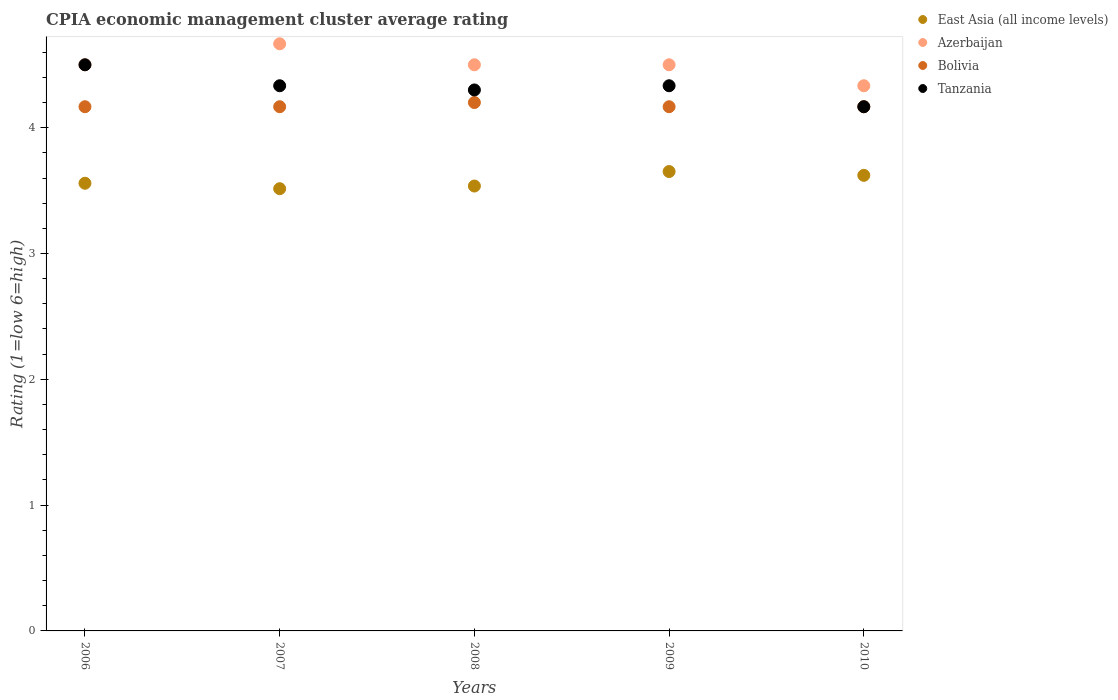How many different coloured dotlines are there?
Provide a succinct answer. 4. Is the number of dotlines equal to the number of legend labels?
Offer a terse response. Yes. What is the CPIA rating in Tanzania in 2009?
Your response must be concise. 4.33. Across all years, what is the maximum CPIA rating in Tanzania?
Offer a very short reply. 4.5. Across all years, what is the minimum CPIA rating in Azerbaijan?
Keep it short and to the point. 4.33. In which year was the CPIA rating in Bolivia maximum?
Ensure brevity in your answer.  2008. What is the total CPIA rating in Tanzania in the graph?
Your response must be concise. 21.63. What is the difference between the CPIA rating in East Asia (all income levels) in 2007 and that in 2010?
Offer a terse response. -0.11. What is the difference between the CPIA rating in Bolivia in 2006 and the CPIA rating in Azerbaijan in 2009?
Your answer should be compact. -0.33. What is the average CPIA rating in Bolivia per year?
Your response must be concise. 4.17. In the year 2008, what is the difference between the CPIA rating in East Asia (all income levels) and CPIA rating in Tanzania?
Your answer should be compact. -0.76. In how many years, is the CPIA rating in East Asia (all income levels) greater than 1?
Your answer should be compact. 5. What is the ratio of the CPIA rating in Bolivia in 2008 to that in 2010?
Give a very brief answer. 1.01. Is the CPIA rating in East Asia (all income levels) in 2007 less than that in 2008?
Your answer should be very brief. Yes. Is the difference between the CPIA rating in East Asia (all income levels) in 2008 and 2009 greater than the difference between the CPIA rating in Tanzania in 2008 and 2009?
Give a very brief answer. No. What is the difference between the highest and the second highest CPIA rating in East Asia (all income levels)?
Give a very brief answer. 0.03. What is the difference between the highest and the lowest CPIA rating in Tanzania?
Provide a succinct answer. 0.33. In how many years, is the CPIA rating in Tanzania greater than the average CPIA rating in Tanzania taken over all years?
Provide a succinct answer. 3. Is the sum of the CPIA rating in East Asia (all income levels) in 2009 and 2010 greater than the maximum CPIA rating in Azerbaijan across all years?
Give a very brief answer. Yes. Is it the case that in every year, the sum of the CPIA rating in Azerbaijan and CPIA rating in Tanzania  is greater than the sum of CPIA rating in East Asia (all income levels) and CPIA rating in Bolivia?
Make the answer very short. No. Does the CPIA rating in Bolivia monotonically increase over the years?
Provide a short and direct response. No. Is the CPIA rating in Azerbaijan strictly less than the CPIA rating in Tanzania over the years?
Provide a short and direct response. No. How many years are there in the graph?
Give a very brief answer. 5. Are the values on the major ticks of Y-axis written in scientific E-notation?
Ensure brevity in your answer.  No. Does the graph contain any zero values?
Ensure brevity in your answer.  No. Does the graph contain grids?
Offer a very short reply. No. What is the title of the graph?
Provide a succinct answer. CPIA economic management cluster average rating. What is the Rating (1=low 6=high) of East Asia (all income levels) in 2006?
Ensure brevity in your answer.  3.56. What is the Rating (1=low 6=high) of Azerbaijan in 2006?
Your answer should be very brief. 4.5. What is the Rating (1=low 6=high) in Bolivia in 2006?
Your answer should be compact. 4.17. What is the Rating (1=low 6=high) of East Asia (all income levels) in 2007?
Your answer should be compact. 3.52. What is the Rating (1=low 6=high) in Azerbaijan in 2007?
Make the answer very short. 4.67. What is the Rating (1=low 6=high) of Bolivia in 2007?
Offer a very short reply. 4.17. What is the Rating (1=low 6=high) in Tanzania in 2007?
Offer a very short reply. 4.33. What is the Rating (1=low 6=high) of East Asia (all income levels) in 2008?
Your response must be concise. 3.54. What is the Rating (1=low 6=high) of Bolivia in 2008?
Ensure brevity in your answer.  4.2. What is the Rating (1=low 6=high) of East Asia (all income levels) in 2009?
Offer a very short reply. 3.65. What is the Rating (1=low 6=high) in Azerbaijan in 2009?
Your answer should be compact. 4.5. What is the Rating (1=low 6=high) of Bolivia in 2009?
Your response must be concise. 4.17. What is the Rating (1=low 6=high) in Tanzania in 2009?
Make the answer very short. 4.33. What is the Rating (1=low 6=high) in East Asia (all income levels) in 2010?
Make the answer very short. 3.62. What is the Rating (1=low 6=high) of Azerbaijan in 2010?
Your answer should be compact. 4.33. What is the Rating (1=low 6=high) of Bolivia in 2010?
Keep it short and to the point. 4.17. What is the Rating (1=low 6=high) of Tanzania in 2010?
Your answer should be compact. 4.17. Across all years, what is the maximum Rating (1=low 6=high) in East Asia (all income levels)?
Your answer should be very brief. 3.65. Across all years, what is the maximum Rating (1=low 6=high) of Azerbaijan?
Offer a very short reply. 4.67. Across all years, what is the minimum Rating (1=low 6=high) in East Asia (all income levels)?
Offer a terse response. 3.52. Across all years, what is the minimum Rating (1=low 6=high) in Azerbaijan?
Provide a short and direct response. 4.33. Across all years, what is the minimum Rating (1=low 6=high) of Bolivia?
Offer a terse response. 4.17. Across all years, what is the minimum Rating (1=low 6=high) of Tanzania?
Your answer should be compact. 4.17. What is the total Rating (1=low 6=high) of East Asia (all income levels) in the graph?
Your answer should be compact. 17.88. What is the total Rating (1=low 6=high) in Bolivia in the graph?
Offer a very short reply. 20.87. What is the total Rating (1=low 6=high) in Tanzania in the graph?
Ensure brevity in your answer.  21.63. What is the difference between the Rating (1=low 6=high) of East Asia (all income levels) in 2006 and that in 2007?
Give a very brief answer. 0.04. What is the difference between the Rating (1=low 6=high) of Bolivia in 2006 and that in 2007?
Keep it short and to the point. 0. What is the difference between the Rating (1=low 6=high) in East Asia (all income levels) in 2006 and that in 2008?
Your answer should be compact. 0.02. What is the difference between the Rating (1=low 6=high) in Azerbaijan in 2006 and that in 2008?
Provide a short and direct response. 0. What is the difference between the Rating (1=low 6=high) in Bolivia in 2006 and that in 2008?
Your response must be concise. -0.03. What is the difference between the Rating (1=low 6=high) in Tanzania in 2006 and that in 2008?
Provide a succinct answer. 0.2. What is the difference between the Rating (1=low 6=high) in East Asia (all income levels) in 2006 and that in 2009?
Ensure brevity in your answer.  -0.09. What is the difference between the Rating (1=low 6=high) of Bolivia in 2006 and that in 2009?
Provide a succinct answer. 0. What is the difference between the Rating (1=low 6=high) in Tanzania in 2006 and that in 2009?
Give a very brief answer. 0.17. What is the difference between the Rating (1=low 6=high) of East Asia (all income levels) in 2006 and that in 2010?
Offer a very short reply. -0.06. What is the difference between the Rating (1=low 6=high) in Bolivia in 2006 and that in 2010?
Provide a short and direct response. 0. What is the difference between the Rating (1=low 6=high) of East Asia (all income levels) in 2007 and that in 2008?
Your response must be concise. -0.02. What is the difference between the Rating (1=low 6=high) in Azerbaijan in 2007 and that in 2008?
Offer a very short reply. 0.17. What is the difference between the Rating (1=low 6=high) of Bolivia in 2007 and that in 2008?
Offer a terse response. -0.03. What is the difference between the Rating (1=low 6=high) of East Asia (all income levels) in 2007 and that in 2009?
Make the answer very short. -0.14. What is the difference between the Rating (1=low 6=high) in Bolivia in 2007 and that in 2009?
Offer a very short reply. 0. What is the difference between the Rating (1=low 6=high) of East Asia (all income levels) in 2007 and that in 2010?
Ensure brevity in your answer.  -0.11. What is the difference between the Rating (1=low 6=high) of Azerbaijan in 2007 and that in 2010?
Give a very brief answer. 0.33. What is the difference between the Rating (1=low 6=high) in Bolivia in 2007 and that in 2010?
Provide a succinct answer. 0. What is the difference between the Rating (1=low 6=high) of East Asia (all income levels) in 2008 and that in 2009?
Offer a terse response. -0.12. What is the difference between the Rating (1=low 6=high) in Bolivia in 2008 and that in 2009?
Ensure brevity in your answer.  0.03. What is the difference between the Rating (1=low 6=high) of Tanzania in 2008 and that in 2009?
Your answer should be very brief. -0.03. What is the difference between the Rating (1=low 6=high) of East Asia (all income levels) in 2008 and that in 2010?
Your response must be concise. -0.08. What is the difference between the Rating (1=low 6=high) of Azerbaijan in 2008 and that in 2010?
Provide a short and direct response. 0.17. What is the difference between the Rating (1=low 6=high) in Bolivia in 2008 and that in 2010?
Make the answer very short. 0.03. What is the difference between the Rating (1=low 6=high) in Tanzania in 2008 and that in 2010?
Provide a succinct answer. 0.13. What is the difference between the Rating (1=low 6=high) in East Asia (all income levels) in 2009 and that in 2010?
Keep it short and to the point. 0.03. What is the difference between the Rating (1=low 6=high) of Bolivia in 2009 and that in 2010?
Offer a very short reply. 0. What is the difference between the Rating (1=low 6=high) in Tanzania in 2009 and that in 2010?
Keep it short and to the point. 0.17. What is the difference between the Rating (1=low 6=high) of East Asia (all income levels) in 2006 and the Rating (1=low 6=high) of Azerbaijan in 2007?
Your answer should be compact. -1.11. What is the difference between the Rating (1=low 6=high) of East Asia (all income levels) in 2006 and the Rating (1=low 6=high) of Bolivia in 2007?
Offer a terse response. -0.61. What is the difference between the Rating (1=low 6=high) of East Asia (all income levels) in 2006 and the Rating (1=low 6=high) of Tanzania in 2007?
Keep it short and to the point. -0.78. What is the difference between the Rating (1=low 6=high) in Azerbaijan in 2006 and the Rating (1=low 6=high) in Bolivia in 2007?
Keep it short and to the point. 0.33. What is the difference between the Rating (1=low 6=high) of Azerbaijan in 2006 and the Rating (1=low 6=high) of Tanzania in 2007?
Provide a short and direct response. 0.17. What is the difference between the Rating (1=low 6=high) in Bolivia in 2006 and the Rating (1=low 6=high) in Tanzania in 2007?
Your response must be concise. -0.17. What is the difference between the Rating (1=low 6=high) of East Asia (all income levels) in 2006 and the Rating (1=low 6=high) of Azerbaijan in 2008?
Offer a very short reply. -0.94. What is the difference between the Rating (1=low 6=high) in East Asia (all income levels) in 2006 and the Rating (1=low 6=high) in Bolivia in 2008?
Provide a short and direct response. -0.64. What is the difference between the Rating (1=low 6=high) of East Asia (all income levels) in 2006 and the Rating (1=low 6=high) of Tanzania in 2008?
Offer a terse response. -0.74. What is the difference between the Rating (1=low 6=high) in Azerbaijan in 2006 and the Rating (1=low 6=high) in Bolivia in 2008?
Provide a succinct answer. 0.3. What is the difference between the Rating (1=low 6=high) of Bolivia in 2006 and the Rating (1=low 6=high) of Tanzania in 2008?
Your answer should be very brief. -0.13. What is the difference between the Rating (1=low 6=high) in East Asia (all income levels) in 2006 and the Rating (1=low 6=high) in Azerbaijan in 2009?
Make the answer very short. -0.94. What is the difference between the Rating (1=low 6=high) in East Asia (all income levels) in 2006 and the Rating (1=low 6=high) in Bolivia in 2009?
Keep it short and to the point. -0.61. What is the difference between the Rating (1=low 6=high) of East Asia (all income levels) in 2006 and the Rating (1=low 6=high) of Tanzania in 2009?
Your answer should be very brief. -0.78. What is the difference between the Rating (1=low 6=high) in Azerbaijan in 2006 and the Rating (1=low 6=high) in Bolivia in 2009?
Give a very brief answer. 0.33. What is the difference between the Rating (1=low 6=high) of Bolivia in 2006 and the Rating (1=low 6=high) of Tanzania in 2009?
Offer a terse response. -0.17. What is the difference between the Rating (1=low 6=high) in East Asia (all income levels) in 2006 and the Rating (1=low 6=high) in Azerbaijan in 2010?
Your answer should be very brief. -0.78. What is the difference between the Rating (1=low 6=high) in East Asia (all income levels) in 2006 and the Rating (1=low 6=high) in Bolivia in 2010?
Offer a very short reply. -0.61. What is the difference between the Rating (1=low 6=high) in East Asia (all income levels) in 2006 and the Rating (1=low 6=high) in Tanzania in 2010?
Your answer should be very brief. -0.61. What is the difference between the Rating (1=low 6=high) in Azerbaijan in 2006 and the Rating (1=low 6=high) in Tanzania in 2010?
Keep it short and to the point. 0.33. What is the difference between the Rating (1=low 6=high) of East Asia (all income levels) in 2007 and the Rating (1=low 6=high) of Azerbaijan in 2008?
Offer a very short reply. -0.98. What is the difference between the Rating (1=low 6=high) of East Asia (all income levels) in 2007 and the Rating (1=low 6=high) of Bolivia in 2008?
Offer a terse response. -0.68. What is the difference between the Rating (1=low 6=high) of East Asia (all income levels) in 2007 and the Rating (1=low 6=high) of Tanzania in 2008?
Ensure brevity in your answer.  -0.78. What is the difference between the Rating (1=low 6=high) in Azerbaijan in 2007 and the Rating (1=low 6=high) in Bolivia in 2008?
Provide a succinct answer. 0.47. What is the difference between the Rating (1=low 6=high) of Azerbaijan in 2007 and the Rating (1=low 6=high) of Tanzania in 2008?
Offer a terse response. 0.37. What is the difference between the Rating (1=low 6=high) in Bolivia in 2007 and the Rating (1=low 6=high) in Tanzania in 2008?
Offer a very short reply. -0.13. What is the difference between the Rating (1=low 6=high) of East Asia (all income levels) in 2007 and the Rating (1=low 6=high) of Azerbaijan in 2009?
Offer a terse response. -0.98. What is the difference between the Rating (1=low 6=high) of East Asia (all income levels) in 2007 and the Rating (1=low 6=high) of Bolivia in 2009?
Provide a short and direct response. -0.65. What is the difference between the Rating (1=low 6=high) of East Asia (all income levels) in 2007 and the Rating (1=low 6=high) of Tanzania in 2009?
Give a very brief answer. -0.82. What is the difference between the Rating (1=low 6=high) in Azerbaijan in 2007 and the Rating (1=low 6=high) in Bolivia in 2009?
Provide a short and direct response. 0.5. What is the difference between the Rating (1=low 6=high) of Azerbaijan in 2007 and the Rating (1=low 6=high) of Tanzania in 2009?
Your answer should be compact. 0.33. What is the difference between the Rating (1=low 6=high) in East Asia (all income levels) in 2007 and the Rating (1=low 6=high) in Azerbaijan in 2010?
Provide a short and direct response. -0.82. What is the difference between the Rating (1=low 6=high) in East Asia (all income levels) in 2007 and the Rating (1=low 6=high) in Bolivia in 2010?
Ensure brevity in your answer.  -0.65. What is the difference between the Rating (1=low 6=high) in East Asia (all income levels) in 2007 and the Rating (1=low 6=high) in Tanzania in 2010?
Give a very brief answer. -0.65. What is the difference between the Rating (1=low 6=high) of Azerbaijan in 2007 and the Rating (1=low 6=high) of Tanzania in 2010?
Ensure brevity in your answer.  0.5. What is the difference between the Rating (1=low 6=high) in Bolivia in 2007 and the Rating (1=low 6=high) in Tanzania in 2010?
Offer a terse response. 0. What is the difference between the Rating (1=low 6=high) in East Asia (all income levels) in 2008 and the Rating (1=low 6=high) in Azerbaijan in 2009?
Provide a short and direct response. -0.96. What is the difference between the Rating (1=low 6=high) of East Asia (all income levels) in 2008 and the Rating (1=low 6=high) of Bolivia in 2009?
Offer a very short reply. -0.63. What is the difference between the Rating (1=low 6=high) in East Asia (all income levels) in 2008 and the Rating (1=low 6=high) in Tanzania in 2009?
Keep it short and to the point. -0.8. What is the difference between the Rating (1=low 6=high) in Azerbaijan in 2008 and the Rating (1=low 6=high) in Tanzania in 2009?
Your response must be concise. 0.17. What is the difference between the Rating (1=low 6=high) of Bolivia in 2008 and the Rating (1=low 6=high) of Tanzania in 2009?
Provide a short and direct response. -0.13. What is the difference between the Rating (1=low 6=high) of East Asia (all income levels) in 2008 and the Rating (1=low 6=high) of Azerbaijan in 2010?
Make the answer very short. -0.8. What is the difference between the Rating (1=low 6=high) in East Asia (all income levels) in 2008 and the Rating (1=low 6=high) in Bolivia in 2010?
Ensure brevity in your answer.  -0.63. What is the difference between the Rating (1=low 6=high) of East Asia (all income levels) in 2008 and the Rating (1=low 6=high) of Tanzania in 2010?
Offer a very short reply. -0.63. What is the difference between the Rating (1=low 6=high) of Azerbaijan in 2008 and the Rating (1=low 6=high) of Tanzania in 2010?
Offer a terse response. 0.33. What is the difference between the Rating (1=low 6=high) of East Asia (all income levels) in 2009 and the Rating (1=low 6=high) of Azerbaijan in 2010?
Offer a terse response. -0.68. What is the difference between the Rating (1=low 6=high) in East Asia (all income levels) in 2009 and the Rating (1=low 6=high) in Bolivia in 2010?
Your answer should be very brief. -0.52. What is the difference between the Rating (1=low 6=high) in East Asia (all income levels) in 2009 and the Rating (1=low 6=high) in Tanzania in 2010?
Keep it short and to the point. -0.52. What is the difference between the Rating (1=low 6=high) in Azerbaijan in 2009 and the Rating (1=low 6=high) in Bolivia in 2010?
Ensure brevity in your answer.  0.33. What is the average Rating (1=low 6=high) of East Asia (all income levels) per year?
Offer a very short reply. 3.58. What is the average Rating (1=low 6=high) of Bolivia per year?
Provide a succinct answer. 4.17. What is the average Rating (1=low 6=high) of Tanzania per year?
Offer a terse response. 4.33. In the year 2006, what is the difference between the Rating (1=low 6=high) of East Asia (all income levels) and Rating (1=low 6=high) of Azerbaijan?
Your answer should be very brief. -0.94. In the year 2006, what is the difference between the Rating (1=low 6=high) in East Asia (all income levels) and Rating (1=low 6=high) in Bolivia?
Provide a succinct answer. -0.61. In the year 2006, what is the difference between the Rating (1=low 6=high) of East Asia (all income levels) and Rating (1=low 6=high) of Tanzania?
Offer a terse response. -0.94. In the year 2006, what is the difference between the Rating (1=low 6=high) in Azerbaijan and Rating (1=low 6=high) in Bolivia?
Your response must be concise. 0.33. In the year 2006, what is the difference between the Rating (1=low 6=high) of Azerbaijan and Rating (1=low 6=high) of Tanzania?
Ensure brevity in your answer.  0. In the year 2006, what is the difference between the Rating (1=low 6=high) in Bolivia and Rating (1=low 6=high) in Tanzania?
Offer a very short reply. -0.33. In the year 2007, what is the difference between the Rating (1=low 6=high) of East Asia (all income levels) and Rating (1=low 6=high) of Azerbaijan?
Ensure brevity in your answer.  -1.15. In the year 2007, what is the difference between the Rating (1=low 6=high) in East Asia (all income levels) and Rating (1=low 6=high) in Bolivia?
Your response must be concise. -0.65. In the year 2007, what is the difference between the Rating (1=low 6=high) in East Asia (all income levels) and Rating (1=low 6=high) in Tanzania?
Give a very brief answer. -0.82. In the year 2007, what is the difference between the Rating (1=low 6=high) in Azerbaijan and Rating (1=low 6=high) in Bolivia?
Your answer should be very brief. 0.5. In the year 2007, what is the difference between the Rating (1=low 6=high) of Azerbaijan and Rating (1=low 6=high) of Tanzania?
Make the answer very short. 0.33. In the year 2007, what is the difference between the Rating (1=low 6=high) in Bolivia and Rating (1=low 6=high) in Tanzania?
Provide a succinct answer. -0.17. In the year 2008, what is the difference between the Rating (1=low 6=high) of East Asia (all income levels) and Rating (1=low 6=high) of Azerbaijan?
Provide a short and direct response. -0.96. In the year 2008, what is the difference between the Rating (1=low 6=high) of East Asia (all income levels) and Rating (1=low 6=high) of Bolivia?
Offer a terse response. -0.66. In the year 2008, what is the difference between the Rating (1=low 6=high) of East Asia (all income levels) and Rating (1=low 6=high) of Tanzania?
Ensure brevity in your answer.  -0.76. In the year 2008, what is the difference between the Rating (1=low 6=high) of Azerbaijan and Rating (1=low 6=high) of Bolivia?
Your response must be concise. 0.3. In the year 2008, what is the difference between the Rating (1=low 6=high) of Azerbaijan and Rating (1=low 6=high) of Tanzania?
Keep it short and to the point. 0.2. In the year 2008, what is the difference between the Rating (1=low 6=high) of Bolivia and Rating (1=low 6=high) of Tanzania?
Make the answer very short. -0.1. In the year 2009, what is the difference between the Rating (1=low 6=high) in East Asia (all income levels) and Rating (1=low 6=high) in Azerbaijan?
Provide a succinct answer. -0.85. In the year 2009, what is the difference between the Rating (1=low 6=high) of East Asia (all income levels) and Rating (1=low 6=high) of Bolivia?
Provide a succinct answer. -0.52. In the year 2009, what is the difference between the Rating (1=low 6=high) of East Asia (all income levels) and Rating (1=low 6=high) of Tanzania?
Provide a short and direct response. -0.68. In the year 2009, what is the difference between the Rating (1=low 6=high) of Azerbaijan and Rating (1=low 6=high) of Bolivia?
Your response must be concise. 0.33. In the year 2009, what is the difference between the Rating (1=low 6=high) of Bolivia and Rating (1=low 6=high) of Tanzania?
Make the answer very short. -0.17. In the year 2010, what is the difference between the Rating (1=low 6=high) of East Asia (all income levels) and Rating (1=low 6=high) of Azerbaijan?
Keep it short and to the point. -0.71. In the year 2010, what is the difference between the Rating (1=low 6=high) of East Asia (all income levels) and Rating (1=low 6=high) of Bolivia?
Make the answer very short. -0.55. In the year 2010, what is the difference between the Rating (1=low 6=high) in East Asia (all income levels) and Rating (1=low 6=high) in Tanzania?
Your answer should be very brief. -0.55. In the year 2010, what is the difference between the Rating (1=low 6=high) of Azerbaijan and Rating (1=low 6=high) of Bolivia?
Your response must be concise. 0.17. What is the ratio of the Rating (1=low 6=high) of East Asia (all income levels) in 2006 to that in 2007?
Give a very brief answer. 1.01. What is the ratio of the Rating (1=low 6=high) of Tanzania in 2006 to that in 2007?
Keep it short and to the point. 1.04. What is the ratio of the Rating (1=low 6=high) of East Asia (all income levels) in 2006 to that in 2008?
Offer a terse response. 1.01. What is the ratio of the Rating (1=low 6=high) in Azerbaijan in 2006 to that in 2008?
Provide a short and direct response. 1. What is the ratio of the Rating (1=low 6=high) in Tanzania in 2006 to that in 2008?
Make the answer very short. 1.05. What is the ratio of the Rating (1=low 6=high) of East Asia (all income levels) in 2006 to that in 2009?
Give a very brief answer. 0.97. What is the ratio of the Rating (1=low 6=high) of Bolivia in 2006 to that in 2009?
Offer a very short reply. 1. What is the ratio of the Rating (1=low 6=high) of East Asia (all income levels) in 2006 to that in 2010?
Your answer should be compact. 0.98. What is the ratio of the Rating (1=low 6=high) of Azerbaijan in 2006 to that in 2010?
Provide a succinct answer. 1.04. What is the ratio of the Rating (1=low 6=high) of Bolivia in 2006 to that in 2010?
Your response must be concise. 1. What is the ratio of the Rating (1=low 6=high) of Tanzania in 2006 to that in 2010?
Keep it short and to the point. 1.08. What is the ratio of the Rating (1=low 6=high) of Tanzania in 2007 to that in 2008?
Provide a short and direct response. 1.01. What is the ratio of the Rating (1=low 6=high) of East Asia (all income levels) in 2007 to that in 2009?
Offer a terse response. 0.96. What is the ratio of the Rating (1=low 6=high) in Bolivia in 2007 to that in 2009?
Provide a short and direct response. 1. What is the ratio of the Rating (1=low 6=high) in East Asia (all income levels) in 2007 to that in 2010?
Make the answer very short. 0.97. What is the ratio of the Rating (1=low 6=high) of Azerbaijan in 2007 to that in 2010?
Provide a short and direct response. 1.08. What is the ratio of the Rating (1=low 6=high) of Tanzania in 2007 to that in 2010?
Give a very brief answer. 1.04. What is the ratio of the Rating (1=low 6=high) in East Asia (all income levels) in 2008 to that in 2009?
Provide a short and direct response. 0.97. What is the ratio of the Rating (1=low 6=high) in Bolivia in 2008 to that in 2009?
Your answer should be very brief. 1.01. What is the ratio of the Rating (1=low 6=high) of Tanzania in 2008 to that in 2009?
Your answer should be compact. 0.99. What is the ratio of the Rating (1=low 6=high) of East Asia (all income levels) in 2008 to that in 2010?
Your answer should be compact. 0.98. What is the ratio of the Rating (1=low 6=high) of Azerbaijan in 2008 to that in 2010?
Ensure brevity in your answer.  1.04. What is the ratio of the Rating (1=low 6=high) in Tanzania in 2008 to that in 2010?
Offer a very short reply. 1.03. What is the ratio of the Rating (1=low 6=high) in East Asia (all income levels) in 2009 to that in 2010?
Give a very brief answer. 1.01. What is the ratio of the Rating (1=low 6=high) in Bolivia in 2009 to that in 2010?
Provide a short and direct response. 1. What is the difference between the highest and the second highest Rating (1=low 6=high) of East Asia (all income levels)?
Keep it short and to the point. 0.03. What is the difference between the highest and the second highest Rating (1=low 6=high) of Bolivia?
Your response must be concise. 0.03. What is the difference between the highest and the lowest Rating (1=low 6=high) in East Asia (all income levels)?
Offer a very short reply. 0.14. What is the difference between the highest and the lowest Rating (1=low 6=high) in Azerbaijan?
Your response must be concise. 0.33. What is the difference between the highest and the lowest Rating (1=low 6=high) in Bolivia?
Your answer should be compact. 0.03. 